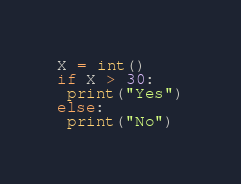<code> <loc_0><loc_0><loc_500><loc_500><_Python_>X = int()
if X > 30:
 print("Yes")
else:
 print("No")</code> 